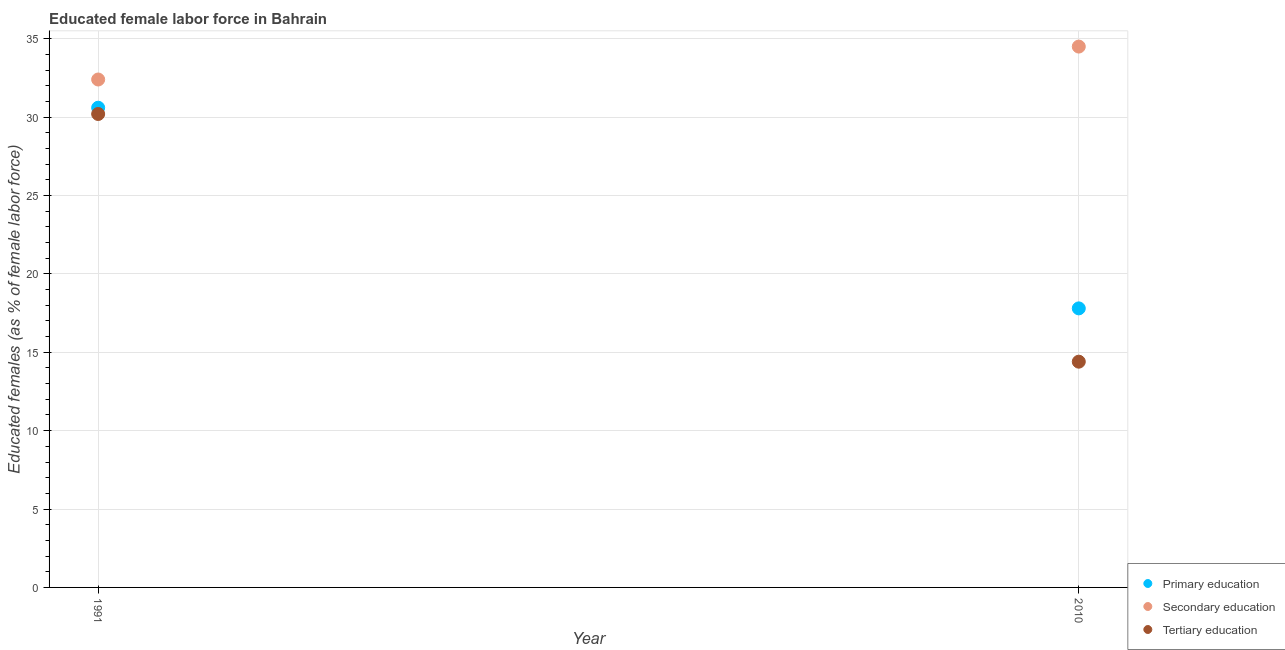How many different coloured dotlines are there?
Your response must be concise. 3. Is the number of dotlines equal to the number of legend labels?
Your answer should be very brief. Yes. What is the percentage of female labor force who received primary education in 2010?
Keep it short and to the point. 17.8. Across all years, what is the maximum percentage of female labor force who received secondary education?
Offer a terse response. 34.5. Across all years, what is the minimum percentage of female labor force who received tertiary education?
Your answer should be very brief. 14.4. What is the total percentage of female labor force who received primary education in the graph?
Offer a terse response. 48.4. What is the difference between the percentage of female labor force who received tertiary education in 1991 and that in 2010?
Provide a succinct answer. 15.8. What is the difference between the percentage of female labor force who received secondary education in 2010 and the percentage of female labor force who received tertiary education in 1991?
Ensure brevity in your answer.  4.3. What is the average percentage of female labor force who received secondary education per year?
Your response must be concise. 33.45. In the year 1991, what is the difference between the percentage of female labor force who received primary education and percentage of female labor force who received tertiary education?
Provide a short and direct response. 0.4. In how many years, is the percentage of female labor force who received secondary education greater than 4 %?
Your response must be concise. 2. What is the ratio of the percentage of female labor force who received primary education in 1991 to that in 2010?
Offer a terse response. 1.72. In how many years, is the percentage of female labor force who received tertiary education greater than the average percentage of female labor force who received tertiary education taken over all years?
Your response must be concise. 1. Is it the case that in every year, the sum of the percentage of female labor force who received primary education and percentage of female labor force who received secondary education is greater than the percentage of female labor force who received tertiary education?
Ensure brevity in your answer.  Yes. What is the difference between two consecutive major ticks on the Y-axis?
Give a very brief answer. 5. Does the graph contain grids?
Give a very brief answer. Yes. Where does the legend appear in the graph?
Ensure brevity in your answer.  Bottom right. How many legend labels are there?
Your response must be concise. 3. What is the title of the graph?
Your answer should be compact. Educated female labor force in Bahrain. Does "Gaseous fuel" appear as one of the legend labels in the graph?
Ensure brevity in your answer.  No. What is the label or title of the X-axis?
Keep it short and to the point. Year. What is the label or title of the Y-axis?
Give a very brief answer. Educated females (as % of female labor force). What is the Educated females (as % of female labor force) of Primary education in 1991?
Make the answer very short. 30.6. What is the Educated females (as % of female labor force) in Secondary education in 1991?
Provide a succinct answer. 32.4. What is the Educated females (as % of female labor force) of Tertiary education in 1991?
Your answer should be compact. 30.2. What is the Educated females (as % of female labor force) in Primary education in 2010?
Your answer should be very brief. 17.8. What is the Educated females (as % of female labor force) of Secondary education in 2010?
Provide a succinct answer. 34.5. What is the Educated females (as % of female labor force) of Tertiary education in 2010?
Make the answer very short. 14.4. Across all years, what is the maximum Educated females (as % of female labor force) of Primary education?
Provide a short and direct response. 30.6. Across all years, what is the maximum Educated females (as % of female labor force) in Secondary education?
Provide a short and direct response. 34.5. Across all years, what is the maximum Educated females (as % of female labor force) in Tertiary education?
Your answer should be compact. 30.2. Across all years, what is the minimum Educated females (as % of female labor force) in Primary education?
Your answer should be compact. 17.8. Across all years, what is the minimum Educated females (as % of female labor force) of Secondary education?
Your answer should be compact. 32.4. Across all years, what is the minimum Educated females (as % of female labor force) in Tertiary education?
Your response must be concise. 14.4. What is the total Educated females (as % of female labor force) in Primary education in the graph?
Your answer should be compact. 48.4. What is the total Educated females (as % of female labor force) of Secondary education in the graph?
Keep it short and to the point. 66.9. What is the total Educated females (as % of female labor force) of Tertiary education in the graph?
Your answer should be very brief. 44.6. What is the average Educated females (as % of female labor force) of Primary education per year?
Your answer should be compact. 24.2. What is the average Educated females (as % of female labor force) in Secondary education per year?
Your answer should be very brief. 33.45. What is the average Educated females (as % of female labor force) of Tertiary education per year?
Provide a succinct answer. 22.3. In the year 1991, what is the difference between the Educated females (as % of female labor force) in Primary education and Educated females (as % of female labor force) in Tertiary education?
Your response must be concise. 0.4. In the year 2010, what is the difference between the Educated females (as % of female labor force) in Primary education and Educated females (as % of female labor force) in Secondary education?
Offer a very short reply. -16.7. In the year 2010, what is the difference between the Educated females (as % of female labor force) of Secondary education and Educated females (as % of female labor force) of Tertiary education?
Your answer should be very brief. 20.1. What is the ratio of the Educated females (as % of female labor force) in Primary education in 1991 to that in 2010?
Ensure brevity in your answer.  1.72. What is the ratio of the Educated females (as % of female labor force) in Secondary education in 1991 to that in 2010?
Your answer should be compact. 0.94. What is the ratio of the Educated females (as % of female labor force) of Tertiary education in 1991 to that in 2010?
Keep it short and to the point. 2.1. What is the difference between the highest and the second highest Educated females (as % of female labor force) in Secondary education?
Make the answer very short. 2.1. What is the difference between the highest and the lowest Educated females (as % of female labor force) in Primary education?
Your answer should be compact. 12.8. What is the difference between the highest and the lowest Educated females (as % of female labor force) in Secondary education?
Ensure brevity in your answer.  2.1. 